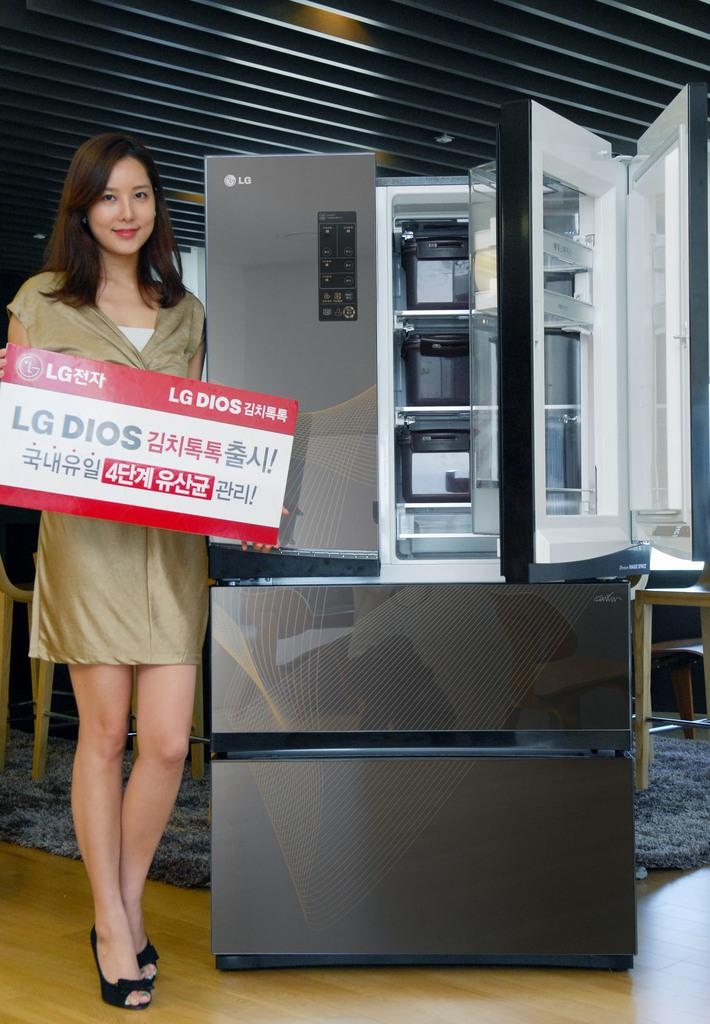<image>
Provide a brief description of the given image. A model holding a sign standing in front of a new LG refrigerator. 